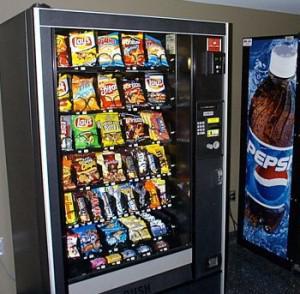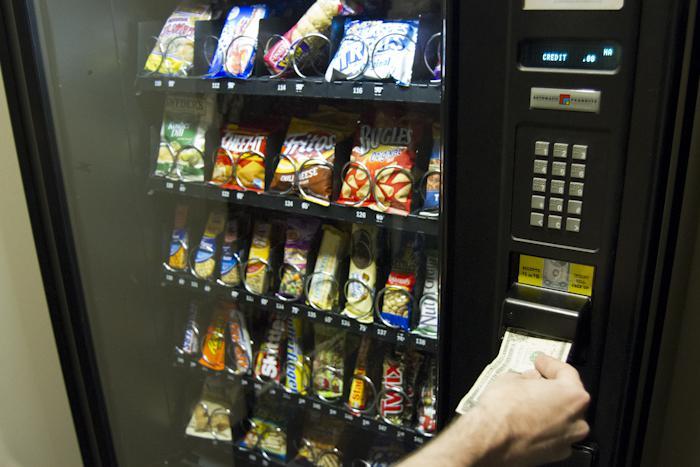The first image is the image on the left, the second image is the image on the right. Evaluate the accuracy of this statement regarding the images: "A part of a human being's body is near a vending machine.". Is it true? Answer yes or no. Yes. The first image is the image on the left, the second image is the image on the right. Considering the images on both sides, is "Left image shows one vending machine displayed straight-on instead of at any angle." valid? Answer yes or no. No. 